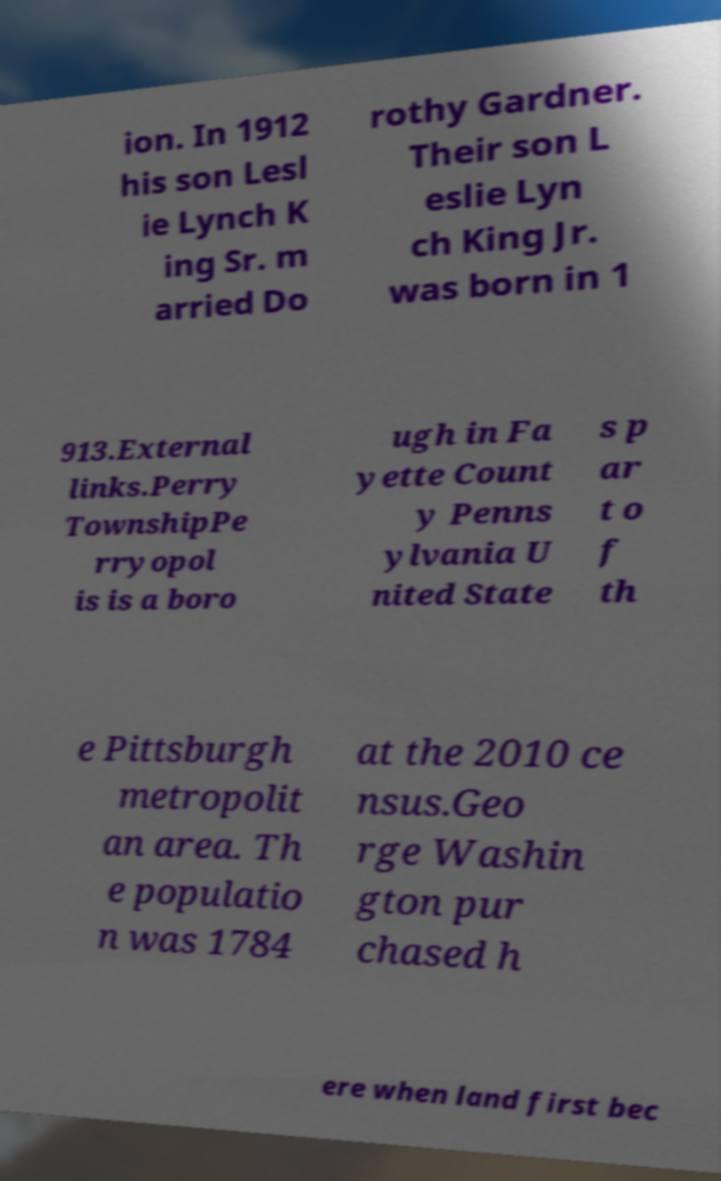Could you extract and type out the text from this image? ion. In 1912 his son Lesl ie Lynch K ing Sr. m arried Do rothy Gardner. Their son L eslie Lyn ch King Jr. was born in 1 913.External links.Perry TownshipPe rryopol is is a boro ugh in Fa yette Count y Penns ylvania U nited State s p ar t o f th e Pittsburgh metropolit an area. Th e populatio n was 1784 at the 2010 ce nsus.Geo rge Washin gton pur chased h ere when land first bec 